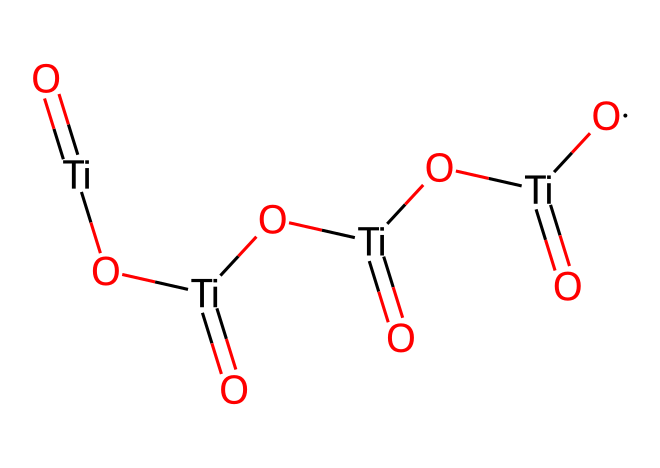What is the central atom in this chemical structure? By examining the SMILES representation, we can see that titanium is denoted by 'Ti' at the beginning. Hence, titanium is the central element in the structure.
Answer: titanium How many titanium atoms are present in this chemical? The SMILES notation reveals 'Ti' listed multiple times. Counting them, we find there are four 'Ti' segments, indicating there are four titanium atoms in the structure.
Answer: four What functional groups are represented in this structure? The presence of 'O' coordinated with 'Ti' shows that there are oxide groups (Ti-O). Each Ti atom is bonded to oxygen, forming metal oxide functional groups.
Answer: metal oxide What is the oxidation state of titanium in this compound? The chemical shows titanium is in multiple bonds with oxygen, indicating it is likely in a +4 oxidation state, common for titanium in oxide forms.
Answer: +4 What type of reactions might titanium dioxide nanoparticles be involved in under UV light? As a photoreactive chemical, titanium dioxide nanoparticles can undergo photocatalytic reactions when exposed to UV light, leading to processes like the breakdown of organic pollutants.
Answer: photocatalytic reactions How does the structure contribute to the photostability of titanium dioxide in sunscreens? The stable arrangement of Ti and O allows for extended exposure to sunlight without degradation, making it effective as a UV filter due to its robust Ti-O bonds.
Answer: stable arrangement 